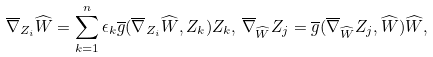Convert formula to latex. <formula><loc_0><loc_0><loc_500><loc_500>& \overline { \nabla } _ { Z _ { i } } \widehat { W } = \sum _ { k = 1 } ^ { n } \epsilon _ { k } \overline { g } ( \overline { \nabla } _ { Z _ { i } } \widehat { W } , Z _ { k } ) Z _ { k } , \, \overline { \nabla } _ { \widehat { W } } Z _ { j } = \overline { g } ( \overline { \nabla } _ { \widehat { W } } Z _ { j } , \widehat { W } ) \widehat { W } ,</formula> 